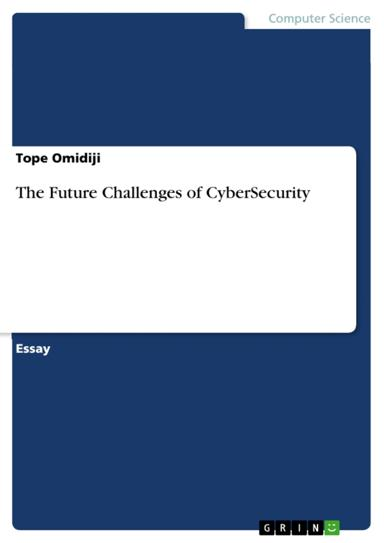What is the title of the essay mentioned in the image? The essay depicted in the image is titled "The Future Challenges of CyberSecurity" and is authored by Tope Omidiji. This essay's title suggests a focus on the evolving nature of online security threats and the strategies that may be employed to counteract these risks. 